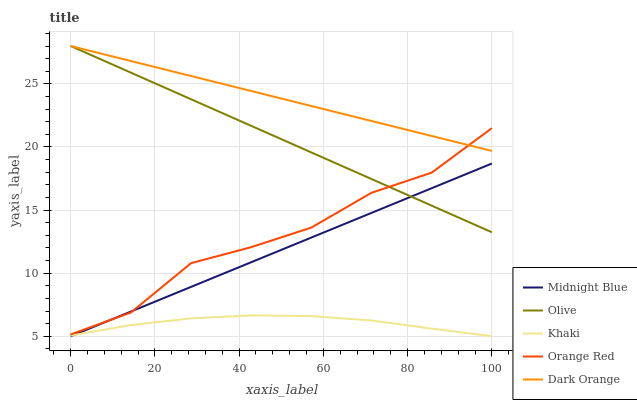Does Khaki have the minimum area under the curve?
Answer yes or no. Yes. Does Dark Orange have the maximum area under the curve?
Answer yes or no. Yes. Does Dark Orange have the minimum area under the curve?
Answer yes or no. No. Does Khaki have the maximum area under the curve?
Answer yes or no. No. Is Midnight Blue the smoothest?
Answer yes or no. Yes. Is Orange Red the roughest?
Answer yes or no. Yes. Is Dark Orange the smoothest?
Answer yes or no. No. Is Dark Orange the roughest?
Answer yes or no. No. Does Dark Orange have the lowest value?
Answer yes or no. No. Does Dark Orange have the highest value?
Answer yes or no. Yes. Does Khaki have the highest value?
Answer yes or no. No. Is Khaki less than Olive?
Answer yes or no. Yes. Is Dark Orange greater than Khaki?
Answer yes or no. Yes. Does Orange Red intersect Olive?
Answer yes or no. Yes. Is Orange Red less than Olive?
Answer yes or no. No. Is Orange Red greater than Olive?
Answer yes or no. No. Does Khaki intersect Olive?
Answer yes or no. No. 